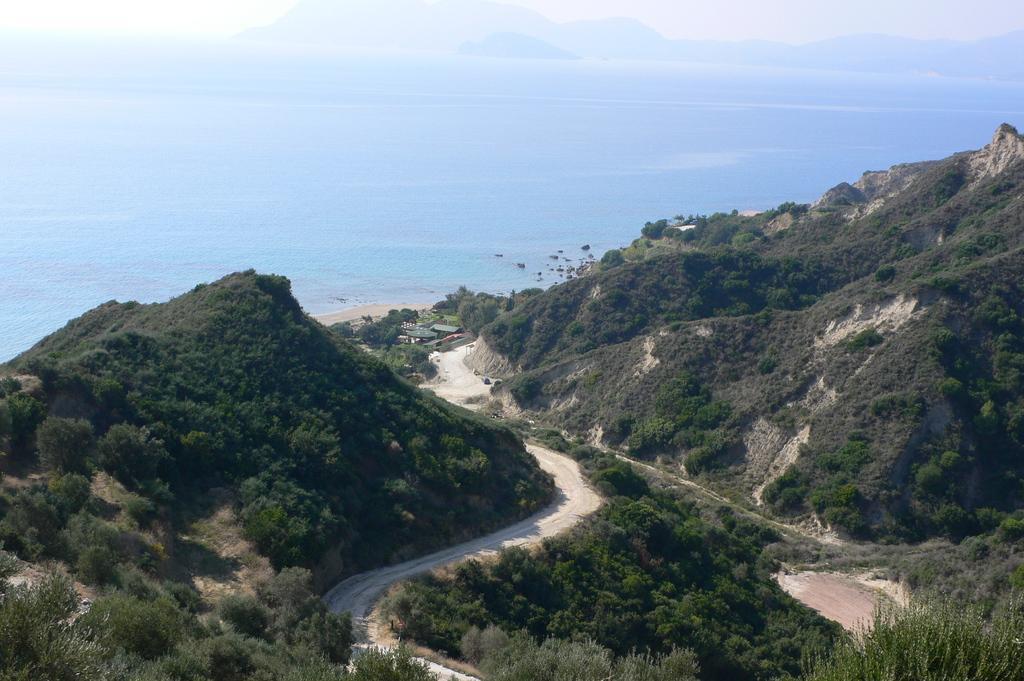Can you describe this image briefly? In this image I can see a road in between the hills, behind I can see water. 